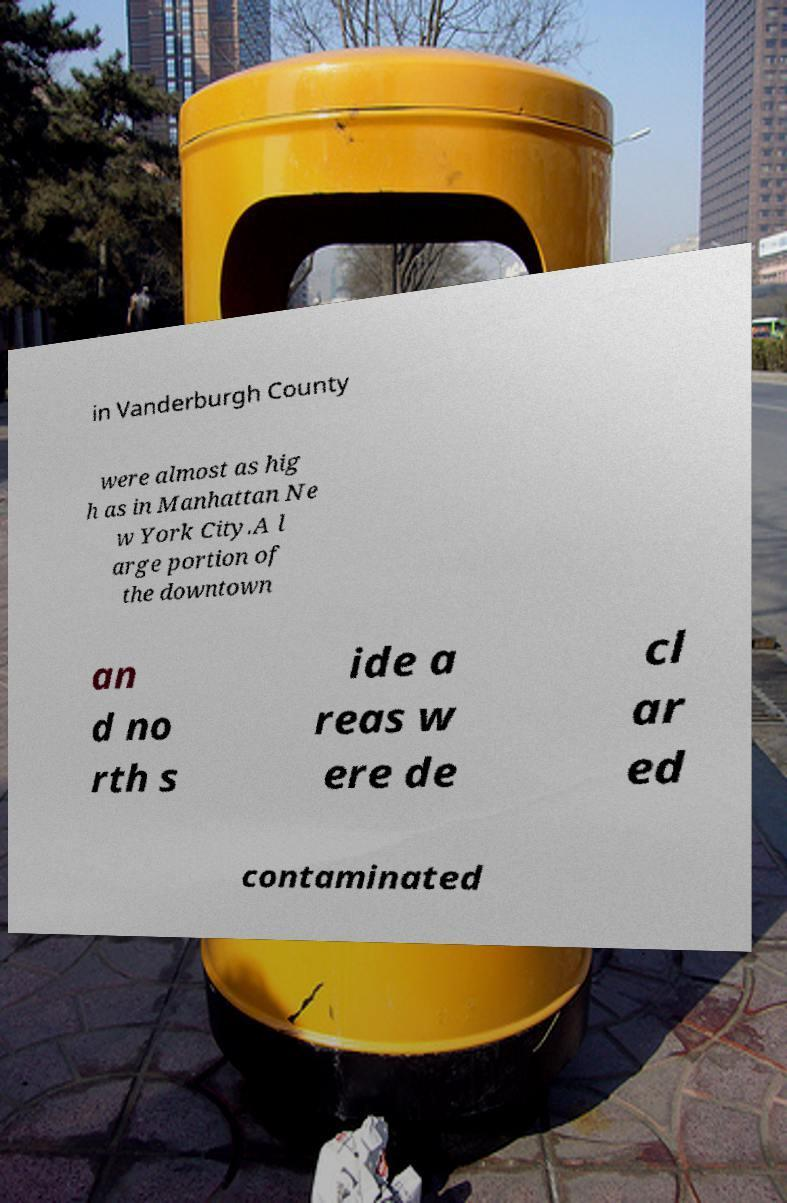Please identify and transcribe the text found in this image. in Vanderburgh County were almost as hig h as in Manhattan Ne w York City.A l arge portion of the downtown an d no rth s ide a reas w ere de cl ar ed contaminated 